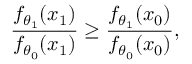<formula> <loc_0><loc_0><loc_500><loc_500>{ \frac { f _ { \theta _ { 1 } } ( x _ { 1 } ) } { f _ { \theta _ { 0 } } ( x _ { 1 } ) } } \geq { \frac { f _ { \theta _ { 1 } } ( x _ { 0 } ) } { f _ { \theta _ { 0 } } ( x _ { 0 } ) } } ,</formula> 